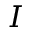<formula> <loc_0><loc_0><loc_500><loc_500>I</formula> 